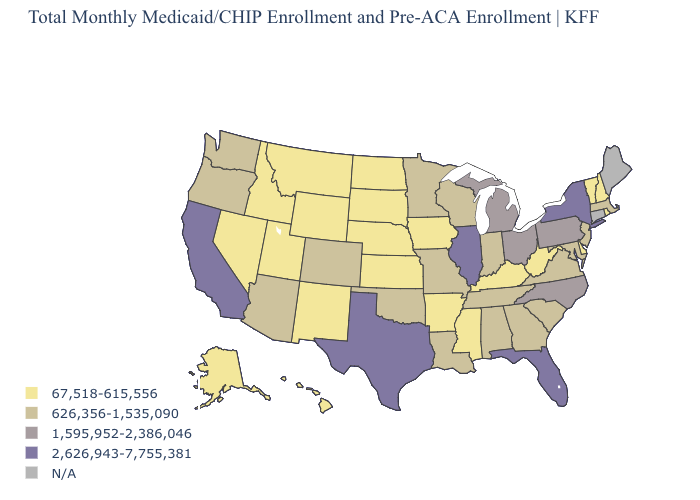What is the value of Wyoming?
Be succinct. 67,518-615,556. Which states have the highest value in the USA?
Short answer required. California, Florida, Illinois, New York, Texas. Among the states that border Louisiana , does Texas have the highest value?
Be succinct. Yes. Does Arkansas have the lowest value in the USA?
Concise answer only. Yes. Name the states that have a value in the range 67,518-615,556?
Short answer required. Alaska, Arkansas, Delaware, Hawaii, Idaho, Iowa, Kansas, Kentucky, Mississippi, Montana, Nebraska, Nevada, New Hampshire, New Mexico, North Dakota, Rhode Island, South Dakota, Utah, Vermont, West Virginia, Wyoming. Does Pennsylvania have the highest value in the USA?
Give a very brief answer. No. What is the lowest value in states that border South Dakota?
Write a very short answer. 67,518-615,556. What is the value of South Carolina?
Quick response, please. 626,356-1,535,090. What is the lowest value in the West?
Keep it brief. 67,518-615,556. What is the value of Kansas?
Answer briefly. 67,518-615,556. What is the highest value in the USA?
Answer briefly. 2,626,943-7,755,381. What is the value of Oregon?
Answer briefly. 626,356-1,535,090. What is the value of Vermont?
Concise answer only. 67,518-615,556. What is the value of Arizona?
Give a very brief answer. 626,356-1,535,090. 